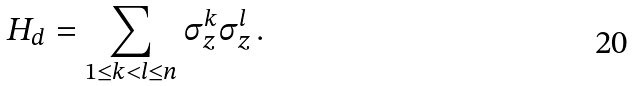Convert formula to latex. <formula><loc_0><loc_0><loc_500><loc_500>H _ { d } = \sum _ { 1 \leq k < l \leq n } \sigma _ { z } ^ { k } \sigma _ { z } ^ { l } \, .</formula> 